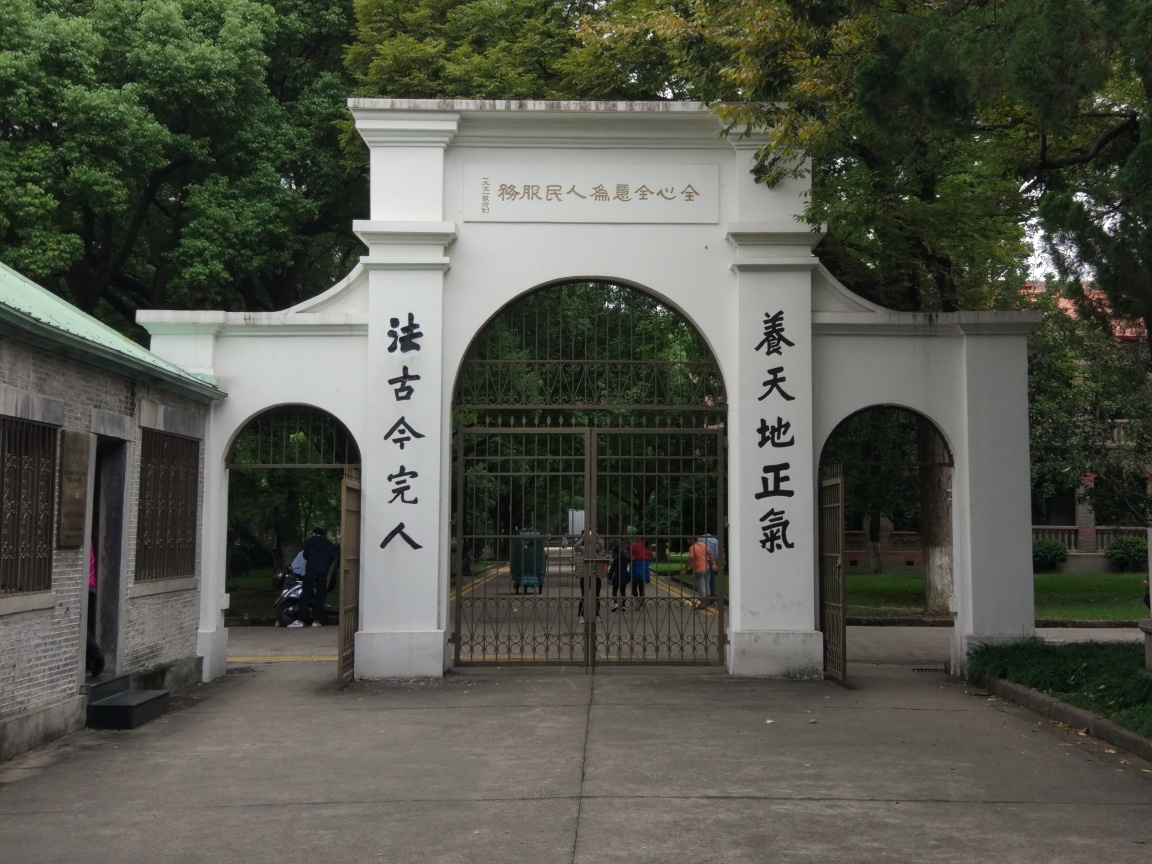Describe the architectural style of the gate. The gate features a traditional Chinese architectural style known as 'paifang', which is an archway typically found in East Asian architecture, often at the entrance to significant locations. It has large white columns supporting a flat roofing structure, inscribed with Chinese calligraphy, and the upper part of the gate is embellished with decorative patterns. It's a style that invokes a sense of respect and reverence, and is commonly seen in places of cultural heritage. 